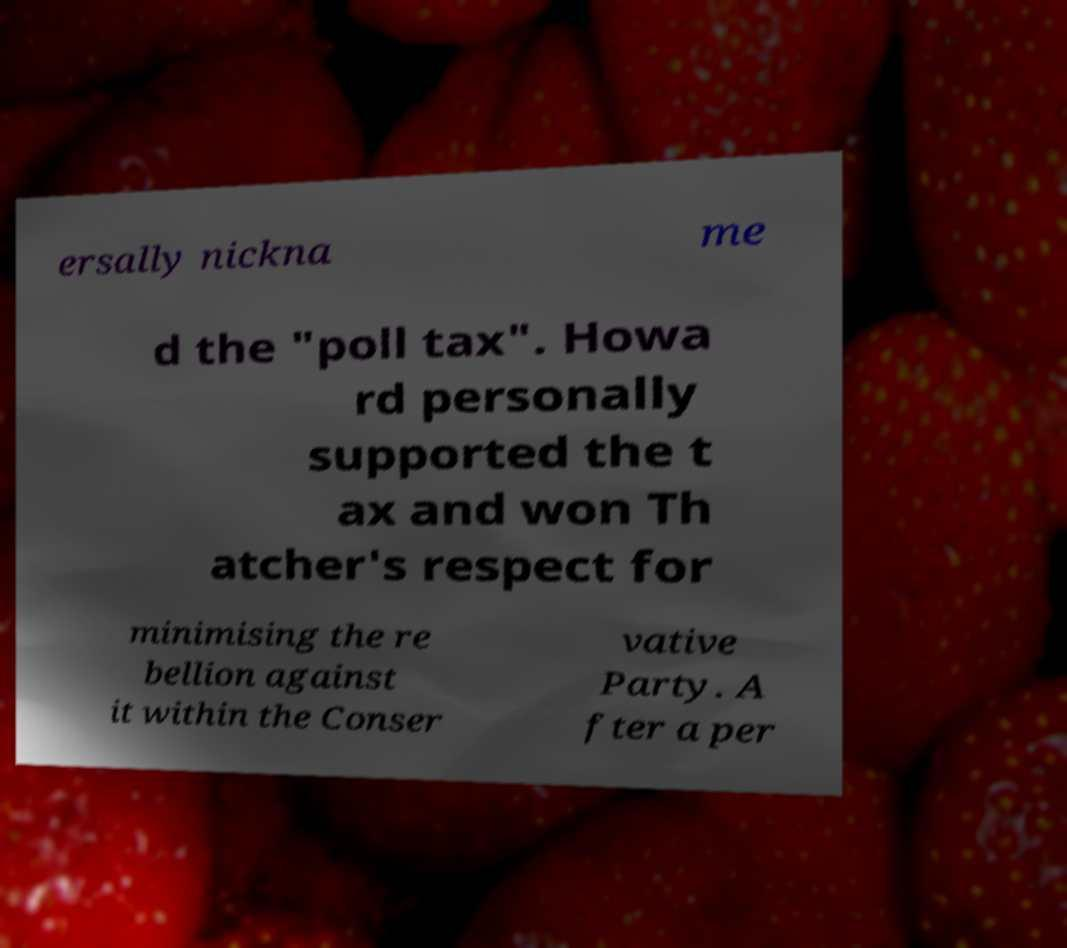There's text embedded in this image that I need extracted. Can you transcribe it verbatim? ersally nickna me d the "poll tax". Howa rd personally supported the t ax and won Th atcher's respect for minimising the re bellion against it within the Conser vative Party. A fter a per 